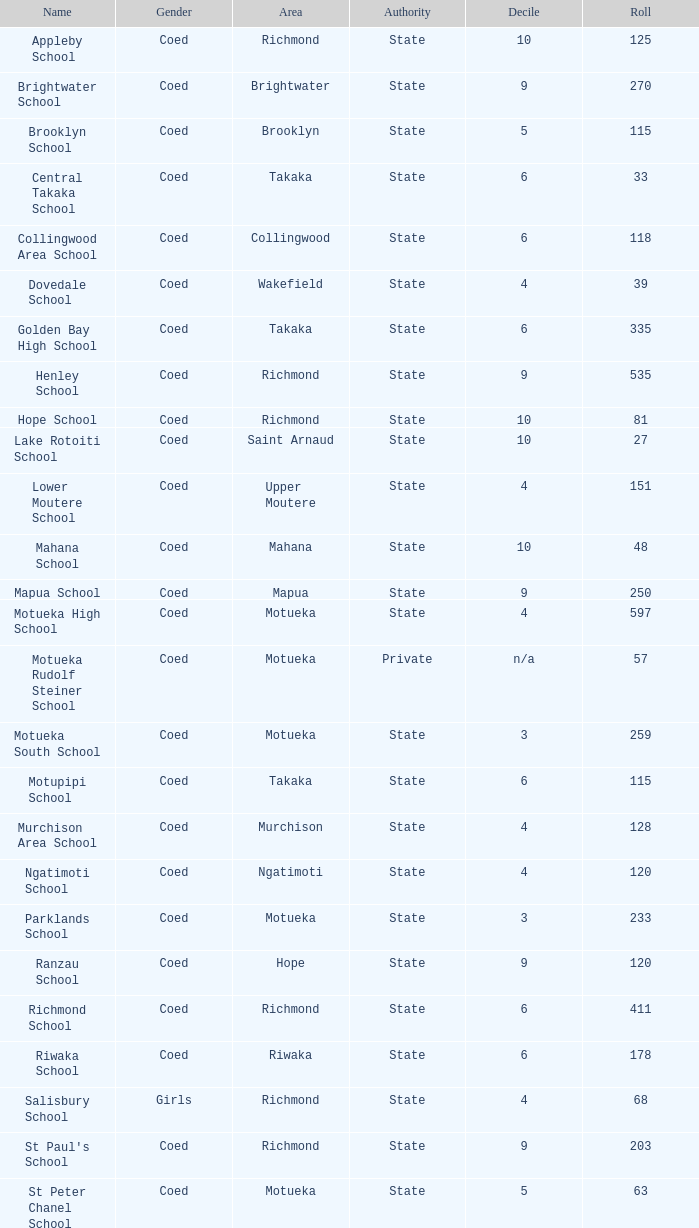In which area is central takaka school located? Takaka. 